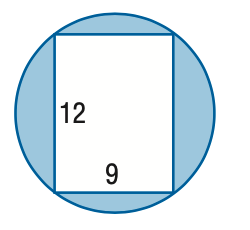Answer the mathemtical geometry problem and directly provide the correct option letter.
Question: Find the area of the shaded region. Round to the nearest tenth.
Choices: A: 24.7 B: 45.9 C: 68.7 D: 119.0 C 